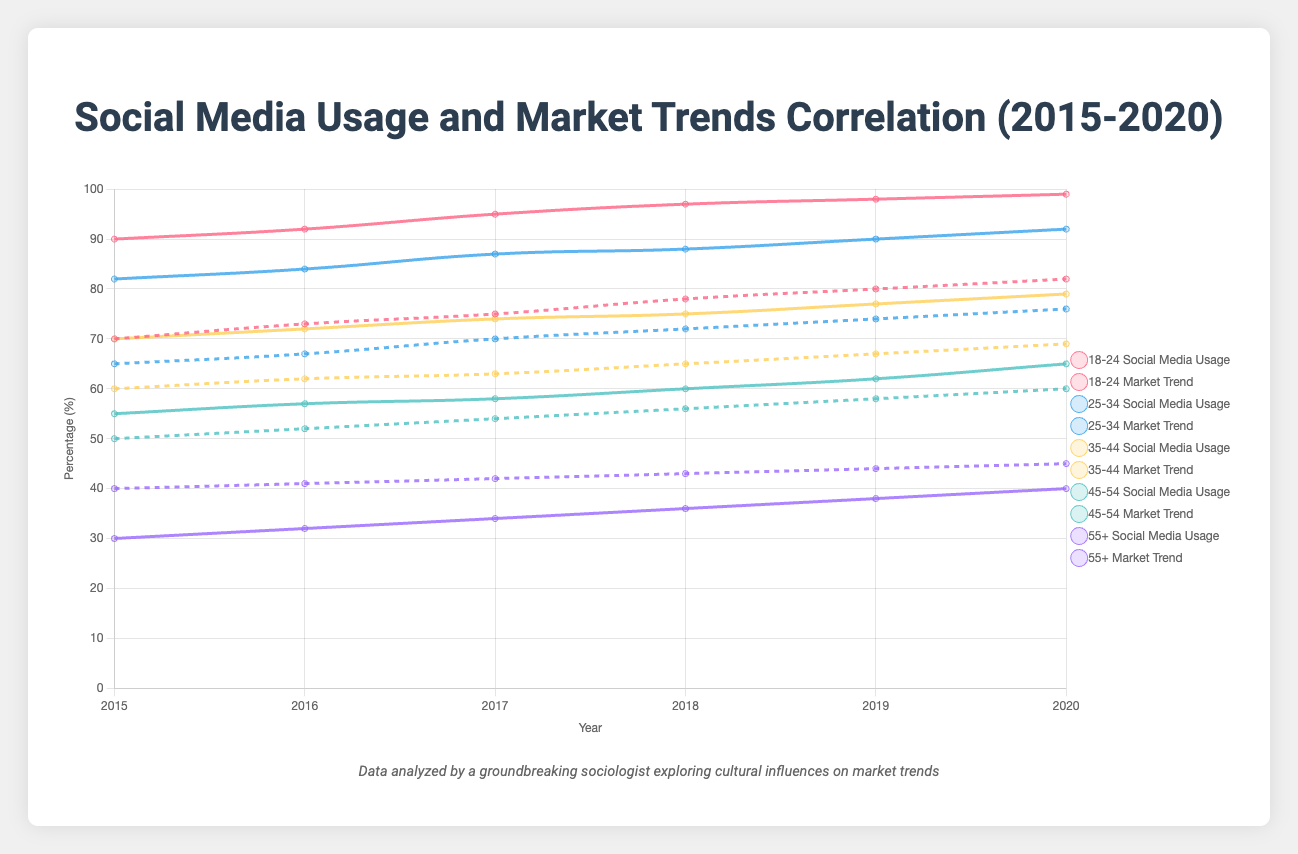What is the trend of social media usage among the 18-24 age group from 2015 to 2020? From the figure, you can see the line representing social media usage for the 18-24 age group from 2015 to 2020. The trend shows an upward slope. Social media usage starts at 90% in 2015 and gradually increases to 99% by 2020.
Answer: Upwards Which age group had the least increase in social media usage between 2015 and 2020? By visually comparing the slopes of the lines for different age groups, you can observe that the 55+ age group shows the smallest increase from 30% in 2015 to 40% in 2020, resulting in a 10% increase. Other age groups have steeper slopes indicating larger increases.
Answer: 55+ Is there a visible correlation between the social media usage and market trend for the age group 25-34 between 2015 and 2020? By comparing the lines for both social media usage and market trend of the 25-34 age group, it is apparent that as social media usage increases, the market trend also shows an upward trend. Both metrics gradually rise each year from 2015 to 2020.
Answer: Yes Which age group had the highest market trend percentage in 2020? Looking at the highest point for market trend lines in 2020 for each age group, the 18-24 age group reaches the highest market trend percentage at 82%. Therefore, 18-24 has the highest market trend percentage in 2020.
Answer: 18-24 Calculate the average increase in social media usage across all age groups from 2015 to 2020. To determine this, calculate the increase for each age group, sum these increases, and then divide by the number of age groups. The increases are: (99-90) for 18-24, (92-82) for 25-34, (79-70) for 35-44, (65-55) for 45-54, and (40-30) for 55+. This results in: (9 + 10 + 9 + 10 + 10) / 5 = 48 / 5 = 9.6.
Answer: 9.6 Between which years did the most significant increase in social media usage for the 35-44 age group occur? By visually examining the slope of the 35-44 social media usage line between each year, the steepest slope is observed between 2017 and 2018, where it rises from 74% to 75%. Therefore, the most notable increase is between these years.
Answer: 2017-2018 